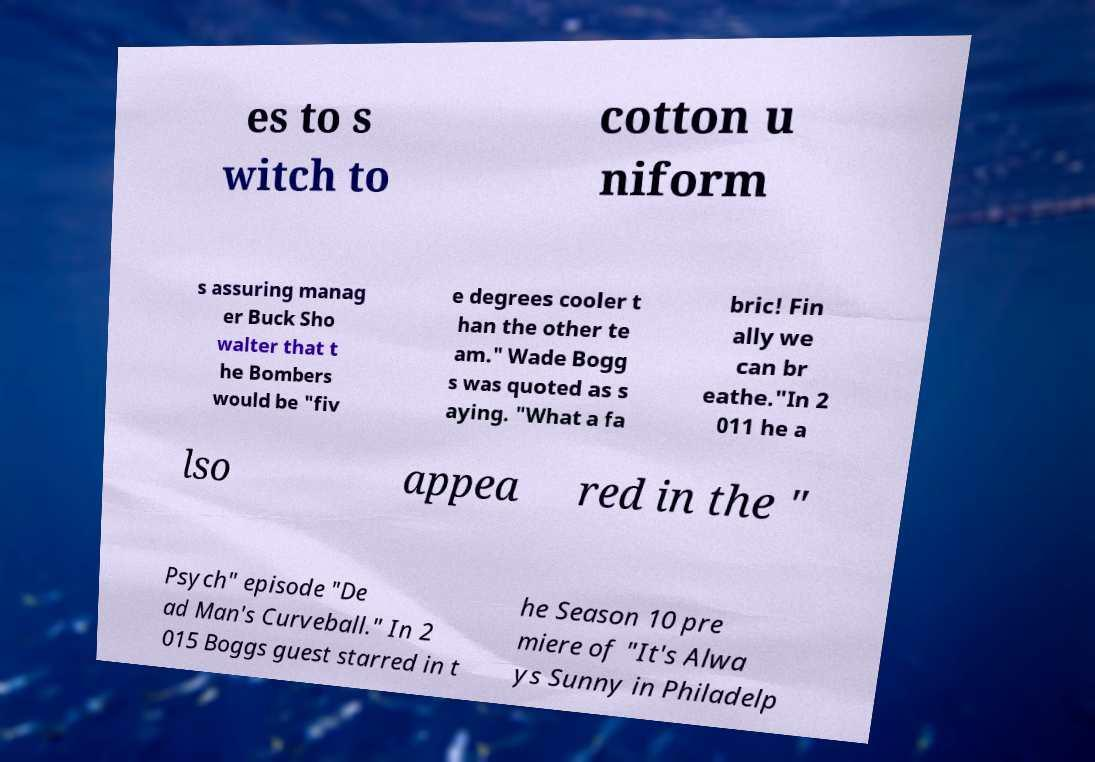Could you assist in decoding the text presented in this image and type it out clearly? es to s witch to cotton u niform s assuring manag er Buck Sho walter that t he Bombers would be "fiv e degrees cooler t han the other te am." Wade Bogg s was quoted as s aying. "What a fa bric! Fin ally we can br eathe."In 2 011 he a lso appea red in the " Psych" episode "De ad Man's Curveball." In 2 015 Boggs guest starred in t he Season 10 pre miere of "It's Alwa ys Sunny in Philadelp 